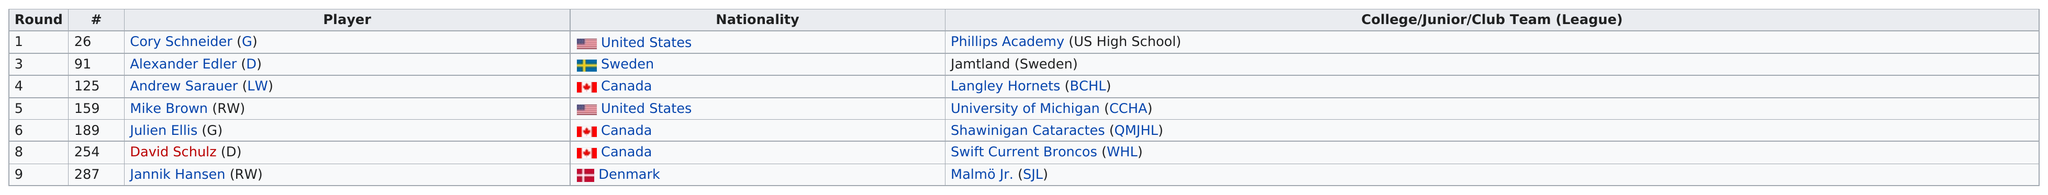Specify some key components in this picture. A total of three Canadian players have been listed. Out of the total number of players, approximately 2% were from the United States," the announcer declared. Andrew Sarauer, a Canadian national and a member of the Langley Hornets, is a left-wing player. Two goalies have been drafted. Jannik Hansen, a right wing player, was the last player to be drafted. 